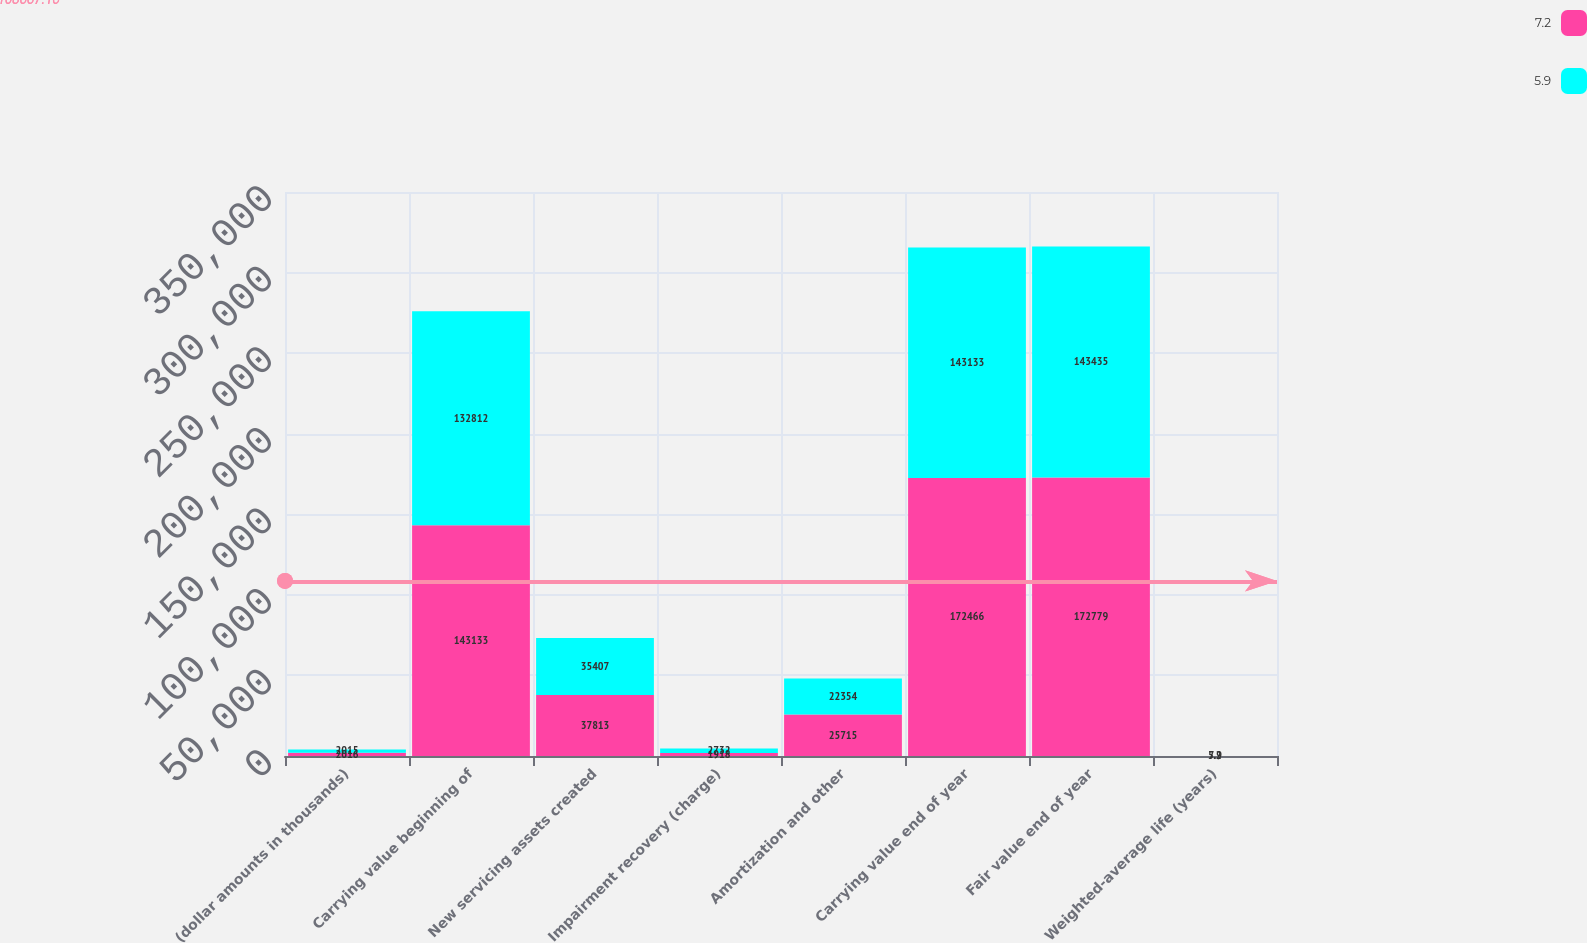Convert chart. <chart><loc_0><loc_0><loc_500><loc_500><stacked_bar_chart><ecel><fcel>(dollar amounts in thousands)<fcel>Carrying value beginning of<fcel>New servicing assets created<fcel>Impairment recovery (charge)<fcel>Amortization and other<fcel>Carrying value end of year<fcel>Fair value end of year<fcel>Weighted-average life (years)<nl><fcel>7.2<fcel>2016<fcel>143133<fcel>37813<fcel>1918<fcel>25715<fcel>172466<fcel>172779<fcel>7.2<nl><fcel>5.9<fcel>2015<fcel>132812<fcel>35407<fcel>2732<fcel>22354<fcel>143133<fcel>143435<fcel>5.9<nl></chart> 